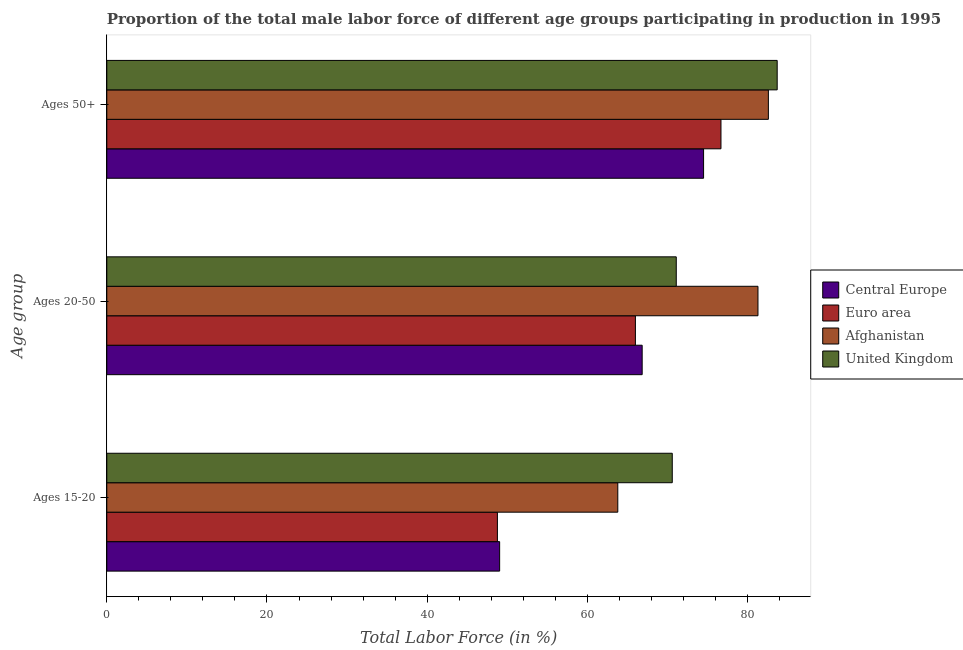How many different coloured bars are there?
Ensure brevity in your answer.  4. How many groups of bars are there?
Keep it short and to the point. 3. Are the number of bars per tick equal to the number of legend labels?
Ensure brevity in your answer.  Yes. Are the number of bars on each tick of the Y-axis equal?
Make the answer very short. Yes. How many bars are there on the 1st tick from the bottom?
Your answer should be very brief. 4. What is the label of the 3rd group of bars from the top?
Provide a succinct answer. Ages 15-20. What is the percentage of male labor force within the age group 20-50 in Afghanistan?
Your answer should be compact. 81.3. Across all countries, what is the maximum percentage of male labor force within the age group 15-20?
Provide a succinct answer. 70.6. Across all countries, what is the minimum percentage of male labor force within the age group 15-20?
Ensure brevity in your answer.  48.77. In which country was the percentage of male labor force within the age group 20-50 maximum?
Provide a succinct answer. Afghanistan. What is the total percentage of male labor force within the age group 20-50 in the graph?
Your response must be concise. 285.24. What is the difference between the percentage of male labor force within the age group 15-20 in Afghanistan and that in Euro area?
Ensure brevity in your answer.  15.03. What is the difference between the percentage of male labor force within the age group 20-50 in Afghanistan and the percentage of male labor force within the age group 15-20 in Central Europe?
Your answer should be compact. 32.25. What is the average percentage of male labor force within the age group 15-20 per country?
Keep it short and to the point. 58.05. What is the difference between the percentage of male labor force within the age group 15-20 and percentage of male labor force within the age group 20-50 in Euro area?
Make the answer very short. -17.23. What is the ratio of the percentage of male labor force within the age group 15-20 in Central Europe to that in Afghanistan?
Your answer should be very brief. 0.77. Is the difference between the percentage of male labor force within the age group 15-20 in Central Europe and Afghanistan greater than the difference between the percentage of male labor force above age 50 in Central Europe and Afghanistan?
Ensure brevity in your answer.  No. What is the difference between the highest and the second highest percentage of male labor force within the age group 15-20?
Provide a succinct answer. 6.8. What is the difference between the highest and the lowest percentage of male labor force above age 50?
Provide a short and direct response. 9.19. How many bars are there?
Provide a short and direct response. 12. Are all the bars in the graph horizontal?
Your response must be concise. Yes. Does the graph contain any zero values?
Ensure brevity in your answer.  No. How many legend labels are there?
Make the answer very short. 4. What is the title of the graph?
Offer a very short reply. Proportion of the total male labor force of different age groups participating in production in 1995. What is the label or title of the Y-axis?
Provide a short and direct response. Age group. What is the Total Labor Force (in %) of Central Europe in Ages 15-20?
Provide a short and direct response. 49.05. What is the Total Labor Force (in %) in Euro area in Ages 15-20?
Provide a short and direct response. 48.77. What is the Total Labor Force (in %) in Afghanistan in Ages 15-20?
Your response must be concise. 63.8. What is the Total Labor Force (in %) in United Kingdom in Ages 15-20?
Give a very brief answer. 70.6. What is the Total Labor Force (in %) of Central Europe in Ages 20-50?
Offer a very short reply. 66.84. What is the Total Labor Force (in %) of Euro area in Ages 20-50?
Offer a very short reply. 66. What is the Total Labor Force (in %) in Afghanistan in Ages 20-50?
Give a very brief answer. 81.3. What is the Total Labor Force (in %) of United Kingdom in Ages 20-50?
Ensure brevity in your answer.  71.1. What is the Total Labor Force (in %) of Central Europe in Ages 50+?
Give a very brief answer. 74.51. What is the Total Labor Force (in %) of Euro area in Ages 50+?
Offer a very short reply. 76.68. What is the Total Labor Force (in %) in Afghanistan in Ages 50+?
Your answer should be very brief. 82.6. What is the Total Labor Force (in %) of United Kingdom in Ages 50+?
Your answer should be very brief. 83.7. Across all Age group, what is the maximum Total Labor Force (in %) in Central Europe?
Provide a succinct answer. 74.51. Across all Age group, what is the maximum Total Labor Force (in %) of Euro area?
Offer a very short reply. 76.68. Across all Age group, what is the maximum Total Labor Force (in %) in Afghanistan?
Your response must be concise. 82.6. Across all Age group, what is the maximum Total Labor Force (in %) in United Kingdom?
Provide a short and direct response. 83.7. Across all Age group, what is the minimum Total Labor Force (in %) in Central Europe?
Your answer should be very brief. 49.05. Across all Age group, what is the minimum Total Labor Force (in %) in Euro area?
Make the answer very short. 48.77. Across all Age group, what is the minimum Total Labor Force (in %) in Afghanistan?
Your answer should be very brief. 63.8. Across all Age group, what is the minimum Total Labor Force (in %) in United Kingdom?
Provide a succinct answer. 70.6. What is the total Total Labor Force (in %) in Central Europe in the graph?
Keep it short and to the point. 190.4. What is the total Total Labor Force (in %) in Euro area in the graph?
Offer a very short reply. 191.45. What is the total Total Labor Force (in %) in Afghanistan in the graph?
Give a very brief answer. 227.7. What is the total Total Labor Force (in %) in United Kingdom in the graph?
Your answer should be very brief. 225.4. What is the difference between the Total Labor Force (in %) of Central Europe in Ages 15-20 and that in Ages 20-50?
Your response must be concise. -17.8. What is the difference between the Total Labor Force (in %) in Euro area in Ages 15-20 and that in Ages 20-50?
Your answer should be compact. -17.23. What is the difference between the Total Labor Force (in %) in Afghanistan in Ages 15-20 and that in Ages 20-50?
Provide a short and direct response. -17.5. What is the difference between the Total Labor Force (in %) of Central Europe in Ages 15-20 and that in Ages 50+?
Provide a succinct answer. -25.46. What is the difference between the Total Labor Force (in %) in Euro area in Ages 15-20 and that in Ages 50+?
Ensure brevity in your answer.  -27.91. What is the difference between the Total Labor Force (in %) of Afghanistan in Ages 15-20 and that in Ages 50+?
Give a very brief answer. -18.8. What is the difference between the Total Labor Force (in %) of United Kingdom in Ages 15-20 and that in Ages 50+?
Offer a very short reply. -13.1. What is the difference between the Total Labor Force (in %) in Central Europe in Ages 20-50 and that in Ages 50+?
Provide a short and direct response. -7.67. What is the difference between the Total Labor Force (in %) in Euro area in Ages 20-50 and that in Ages 50+?
Provide a short and direct response. -10.68. What is the difference between the Total Labor Force (in %) in Afghanistan in Ages 20-50 and that in Ages 50+?
Provide a short and direct response. -1.3. What is the difference between the Total Labor Force (in %) of United Kingdom in Ages 20-50 and that in Ages 50+?
Provide a succinct answer. -12.6. What is the difference between the Total Labor Force (in %) of Central Europe in Ages 15-20 and the Total Labor Force (in %) of Euro area in Ages 20-50?
Offer a terse response. -16.95. What is the difference between the Total Labor Force (in %) in Central Europe in Ages 15-20 and the Total Labor Force (in %) in Afghanistan in Ages 20-50?
Your answer should be compact. -32.25. What is the difference between the Total Labor Force (in %) of Central Europe in Ages 15-20 and the Total Labor Force (in %) of United Kingdom in Ages 20-50?
Provide a succinct answer. -22.05. What is the difference between the Total Labor Force (in %) of Euro area in Ages 15-20 and the Total Labor Force (in %) of Afghanistan in Ages 20-50?
Ensure brevity in your answer.  -32.53. What is the difference between the Total Labor Force (in %) in Euro area in Ages 15-20 and the Total Labor Force (in %) in United Kingdom in Ages 20-50?
Give a very brief answer. -22.33. What is the difference between the Total Labor Force (in %) in Afghanistan in Ages 15-20 and the Total Labor Force (in %) in United Kingdom in Ages 20-50?
Offer a terse response. -7.3. What is the difference between the Total Labor Force (in %) of Central Europe in Ages 15-20 and the Total Labor Force (in %) of Euro area in Ages 50+?
Ensure brevity in your answer.  -27.63. What is the difference between the Total Labor Force (in %) of Central Europe in Ages 15-20 and the Total Labor Force (in %) of Afghanistan in Ages 50+?
Provide a short and direct response. -33.55. What is the difference between the Total Labor Force (in %) of Central Europe in Ages 15-20 and the Total Labor Force (in %) of United Kingdom in Ages 50+?
Give a very brief answer. -34.65. What is the difference between the Total Labor Force (in %) of Euro area in Ages 15-20 and the Total Labor Force (in %) of Afghanistan in Ages 50+?
Offer a very short reply. -33.83. What is the difference between the Total Labor Force (in %) of Euro area in Ages 15-20 and the Total Labor Force (in %) of United Kingdom in Ages 50+?
Provide a succinct answer. -34.93. What is the difference between the Total Labor Force (in %) of Afghanistan in Ages 15-20 and the Total Labor Force (in %) of United Kingdom in Ages 50+?
Your answer should be compact. -19.9. What is the difference between the Total Labor Force (in %) of Central Europe in Ages 20-50 and the Total Labor Force (in %) of Euro area in Ages 50+?
Ensure brevity in your answer.  -9.84. What is the difference between the Total Labor Force (in %) of Central Europe in Ages 20-50 and the Total Labor Force (in %) of Afghanistan in Ages 50+?
Ensure brevity in your answer.  -15.76. What is the difference between the Total Labor Force (in %) in Central Europe in Ages 20-50 and the Total Labor Force (in %) in United Kingdom in Ages 50+?
Give a very brief answer. -16.86. What is the difference between the Total Labor Force (in %) in Euro area in Ages 20-50 and the Total Labor Force (in %) in Afghanistan in Ages 50+?
Provide a succinct answer. -16.6. What is the difference between the Total Labor Force (in %) of Euro area in Ages 20-50 and the Total Labor Force (in %) of United Kingdom in Ages 50+?
Your response must be concise. -17.7. What is the average Total Labor Force (in %) of Central Europe per Age group?
Provide a succinct answer. 63.47. What is the average Total Labor Force (in %) of Euro area per Age group?
Your answer should be compact. 63.82. What is the average Total Labor Force (in %) of Afghanistan per Age group?
Offer a very short reply. 75.9. What is the average Total Labor Force (in %) in United Kingdom per Age group?
Offer a very short reply. 75.13. What is the difference between the Total Labor Force (in %) of Central Europe and Total Labor Force (in %) of Euro area in Ages 15-20?
Make the answer very short. 0.28. What is the difference between the Total Labor Force (in %) in Central Europe and Total Labor Force (in %) in Afghanistan in Ages 15-20?
Keep it short and to the point. -14.75. What is the difference between the Total Labor Force (in %) of Central Europe and Total Labor Force (in %) of United Kingdom in Ages 15-20?
Offer a terse response. -21.55. What is the difference between the Total Labor Force (in %) of Euro area and Total Labor Force (in %) of Afghanistan in Ages 15-20?
Ensure brevity in your answer.  -15.03. What is the difference between the Total Labor Force (in %) in Euro area and Total Labor Force (in %) in United Kingdom in Ages 15-20?
Your response must be concise. -21.83. What is the difference between the Total Labor Force (in %) in Central Europe and Total Labor Force (in %) in Euro area in Ages 20-50?
Offer a very short reply. 0.85. What is the difference between the Total Labor Force (in %) of Central Europe and Total Labor Force (in %) of Afghanistan in Ages 20-50?
Provide a succinct answer. -14.46. What is the difference between the Total Labor Force (in %) in Central Europe and Total Labor Force (in %) in United Kingdom in Ages 20-50?
Give a very brief answer. -4.26. What is the difference between the Total Labor Force (in %) in Euro area and Total Labor Force (in %) in Afghanistan in Ages 20-50?
Your answer should be compact. -15.3. What is the difference between the Total Labor Force (in %) of Euro area and Total Labor Force (in %) of United Kingdom in Ages 20-50?
Offer a terse response. -5.1. What is the difference between the Total Labor Force (in %) of Central Europe and Total Labor Force (in %) of Euro area in Ages 50+?
Give a very brief answer. -2.17. What is the difference between the Total Labor Force (in %) of Central Europe and Total Labor Force (in %) of Afghanistan in Ages 50+?
Ensure brevity in your answer.  -8.09. What is the difference between the Total Labor Force (in %) of Central Europe and Total Labor Force (in %) of United Kingdom in Ages 50+?
Ensure brevity in your answer.  -9.19. What is the difference between the Total Labor Force (in %) of Euro area and Total Labor Force (in %) of Afghanistan in Ages 50+?
Your response must be concise. -5.92. What is the difference between the Total Labor Force (in %) of Euro area and Total Labor Force (in %) of United Kingdom in Ages 50+?
Ensure brevity in your answer.  -7.02. What is the difference between the Total Labor Force (in %) of Afghanistan and Total Labor Force (in %) of United Kingdom in Ages 50+?
Provide a short and direct response. -1.1. What is the ratio of the Total Labor Force (in %) in Central Europe in Ages 15-20 to that in Ages 20-50?
Ensure brevity in your answer.  0.73. What is the ratio of the Total Labor Force (in %) in Euro area in Ages 15-20 to that in Ages 20-50?
Give a very brief answer. 0.74. What is the ratio of the Total Labor Force (in %) of Afghanistan in Ages 15-20 to that in Ages 20-50?
Keep it short and to the point. 0.78. What is the ratio of the Total Labor Force (in %) of Central Europe in Ages 15-20 to that in Ages 50+?
Your answer should be compact. 0.66. What is the ratio of the Total Labor Force (in %) of Euro area in Ages 15-20 to that in Ages 50+?
Your response must be concise. 0.64. What is the ratio of the Total Labor Force (in %) of Afghanistan in Ages 15-20 to that in Ages 50+?
Give a very brief answer. 0.77. What is the ratio of the Total Labor Force (in %) in United Kingdom in Ages 15-20 to that in Ages 50+?
Give a very brief answer. 0.84. What is the ratio of the Total Labor Force (in %) in Central Europe in Ages 20-50 to that in Ages 50+?
Your response must be concise. 0.9. What is the ratio of the Total Labor Force (in %) of Euro area in Ages 20-50 to that in Ages 50+?
Provide a succinct answer. 0.86. What is the ratio of the Total Labor Force (in %) in Afghanistan in Ages 20-50 to that in Ages 50+?
Ensure brevity in your answer.  0.98. What is the ratio of the Total Labor Force (in %) of United Kingdom in Ages 20-50 to that in Ages 50+?
Ensure brevity in your answer.  0.85. What is the difference between the highest and the second highest Total Labor Force (in %) of Central Europe?
Offer a terse response. 7.67. What is the difference between the highest and the second highest Total Labor Force (in %) in Euro area?
Your answer should be compact. 10.68. What is the difference between the highest and the second highest Total Labor Force (in %) of Afghanistan?
Your answer should be very brief. 1.3. What is the difference between the highest and the second highest Total Labor Force (in %) of United Kingdom?
Your answer should be very brief. 12.6. What is the difference between the highest and the lowest Total Labor Force (in %) in Central Europe?
Provide a succinct answer. 25.46. What is the difference between the highest and the lowest Total Labor Force (in %) in Euro area?
Keep it short and to the point. 27.91. What is the difference between the highest and the lowest Total Labor Force (in %) in United Kingdom?
Make the answer very short. 13.1. 